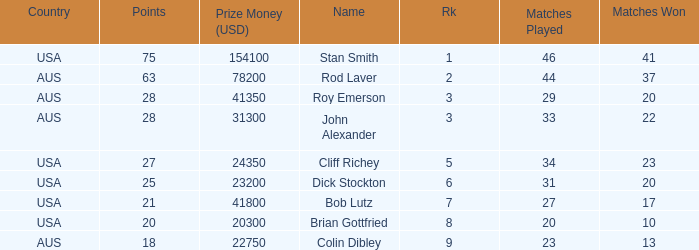How many matches did the player that played 23 matches win 13.0. 